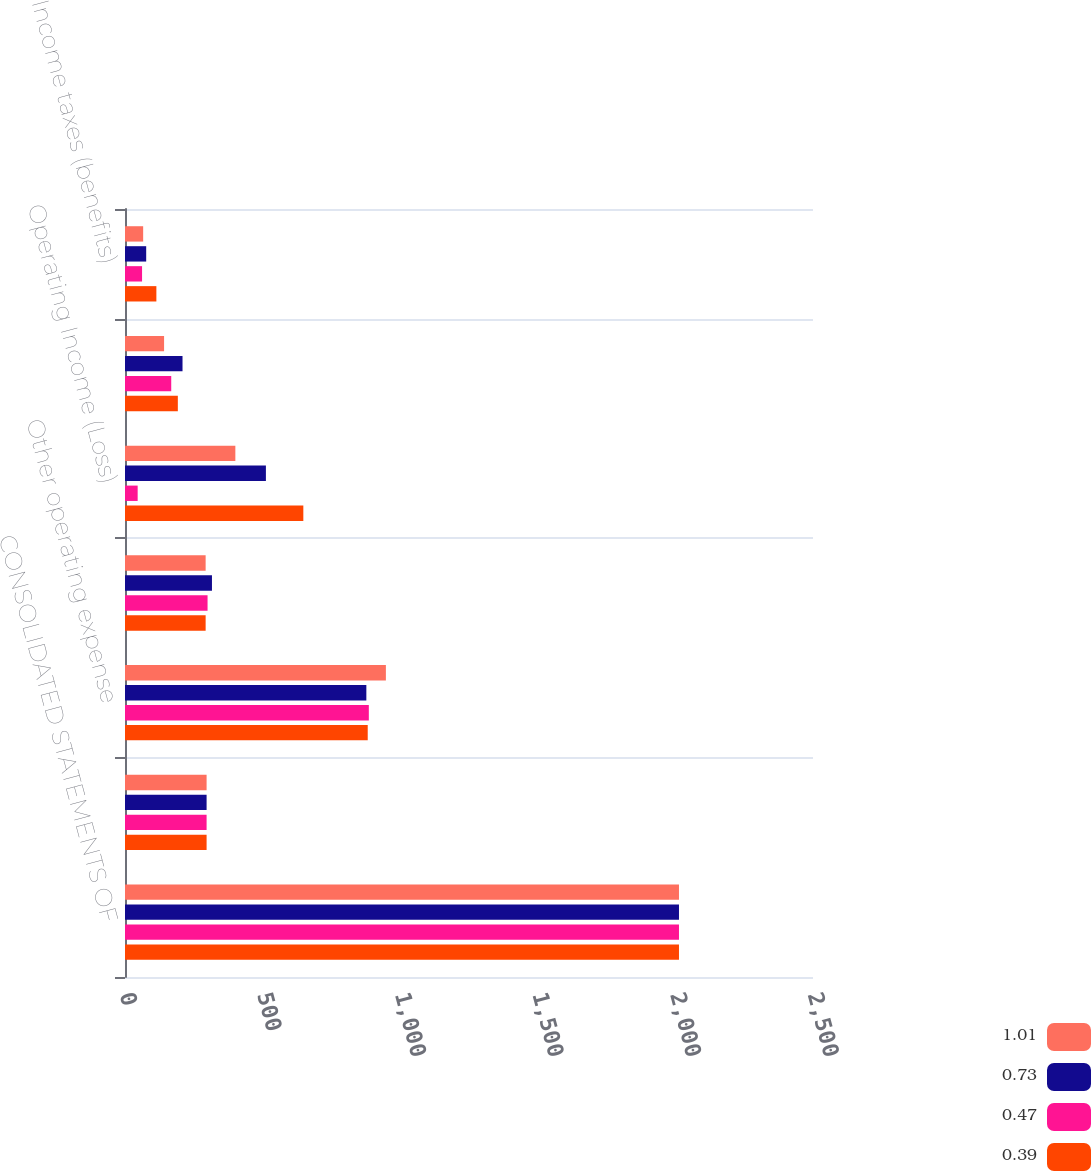<chart> <loc_0><loc_0><loc_500><loc_500><stacked_bar_chart><ecel><fcel>CONSOLIDATED STATEMENTS OF<fcel>Revenues<fcel>Other operating expense<fcel>Provision for depreciation<fcel>Operating Income (Loss)<fcel>Income (loss) from continuing<fcel>Income taxes (benefits)<nl><fcel>1.01<fcel>2013<fcel>296.5<fcel>948<fcel>293<fcel>401<fcel>142<fcel>66<nl><fcel>0.73<fcel>2013<fcel>296.5<fcel>877<fcel>316<fcel>512<fcel>209<fcel>77<nl><fcel>0.47<fcel>2013<fcel>296.5<fcel>886<fcel>300<fcel>46<fcel>168<fcel>62<nl><fcel>0.39<fcel>2013<fcel>296.5<fcel>882<fcel>293<fcel>648<fcel>192<fcel>114<nl></chart> 